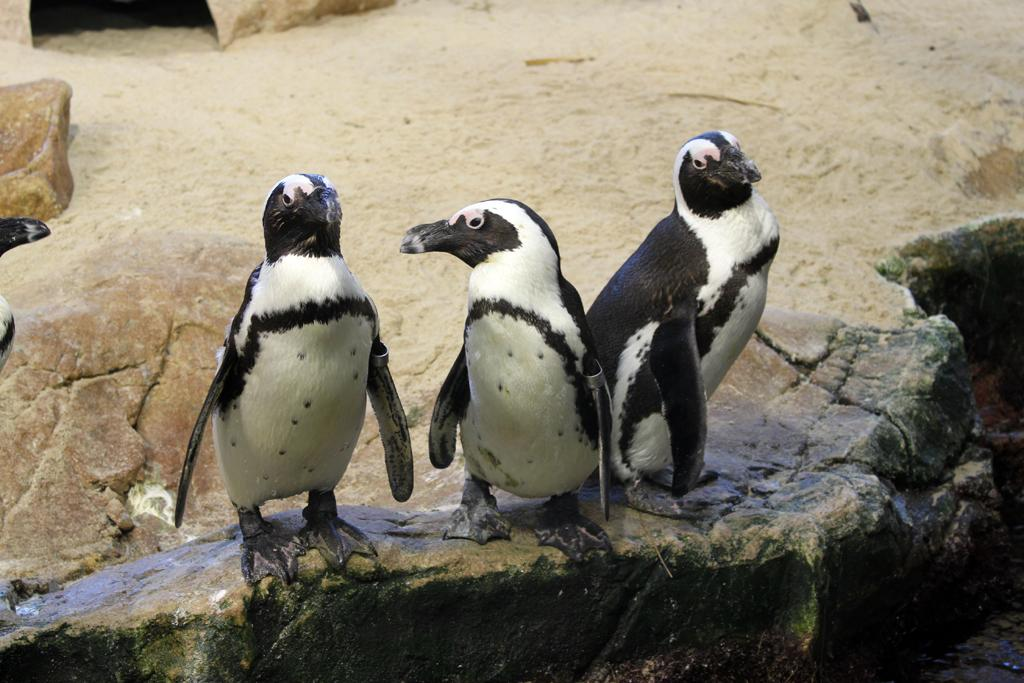What type of animals are in the image? There are penguins in the image. Where are the penguins located? The penguins are on a rock. Can you describe the position of the rock in the image? The rock is in the center of the image. What type of business is being conducted by the bear in the image? There is no bear present in the image, and therefore no business can be conducted by a bear. 